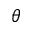<formula> <loc_0><loc_0><loc_500><loc_500>\theta</formula> 